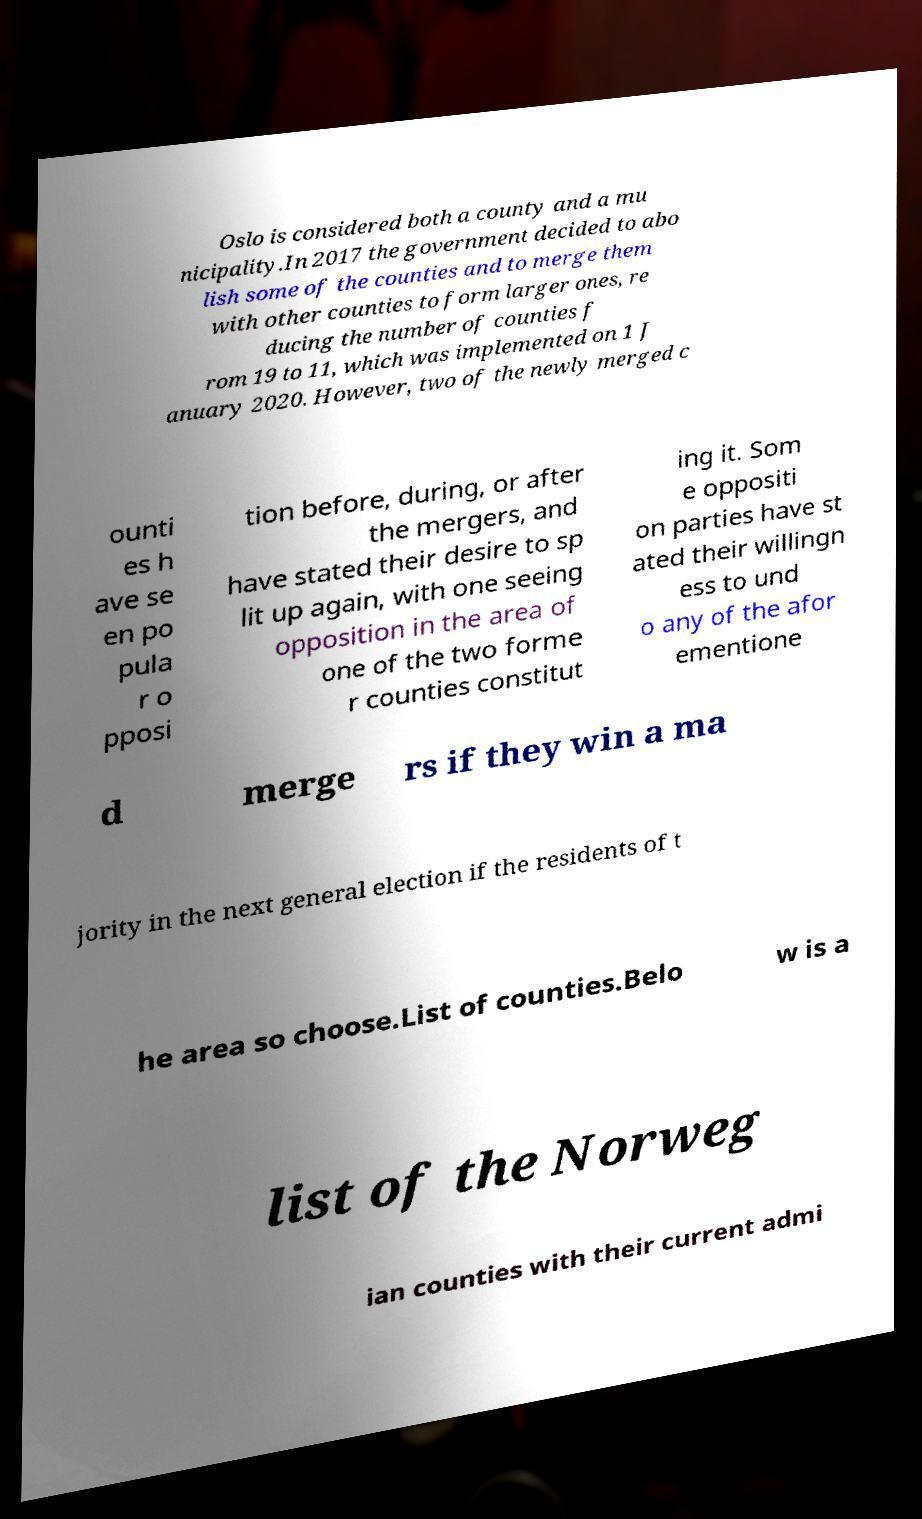Could you extract and type out the text from this image? Oslo is considered both a county and a mu nicipality.In 2017 the government decided to abo lish some of the counties and to merge them with other counties to form larger ones, re ducing the number of counties f rom 19 to 11, which was implemented on 1 J anuary 2020. However, two of the newly merged c ounti es h ave se en po pula r o pposi tion before, during, or after the mergers, and have stated their desire to sp lit up again, with one seeing opposition in the area of one of the two forme r counties constitut ing it. Som e oppositi on parties have st ated their willingn ess to und o any of the afor ementione d merge rs if they win a ma jority in the next general election if the residents of t he area so choose.List of counties.Belo w is a list of the Norweg ian counties with their current admi 